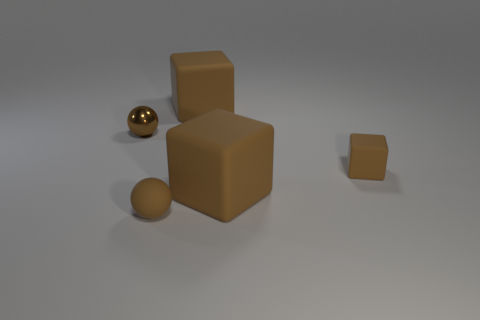How many brown cubes must be subtracted to get 1 brown cubes? 2 Add 5 small brown metallic objects. How many objects exist? 10 Subtract all spheres. How many objects are left? 3 Add 3 big yellow objects. How many big yellow objects exist? 3 Subtract 0 purple spheres. How many objects are left? 5 Subtract all rubber balls. Subtract all small green shiny blocks. How many objects are left? 4 Add 3 tiny blocks. How many tiny blocks are left? 4 